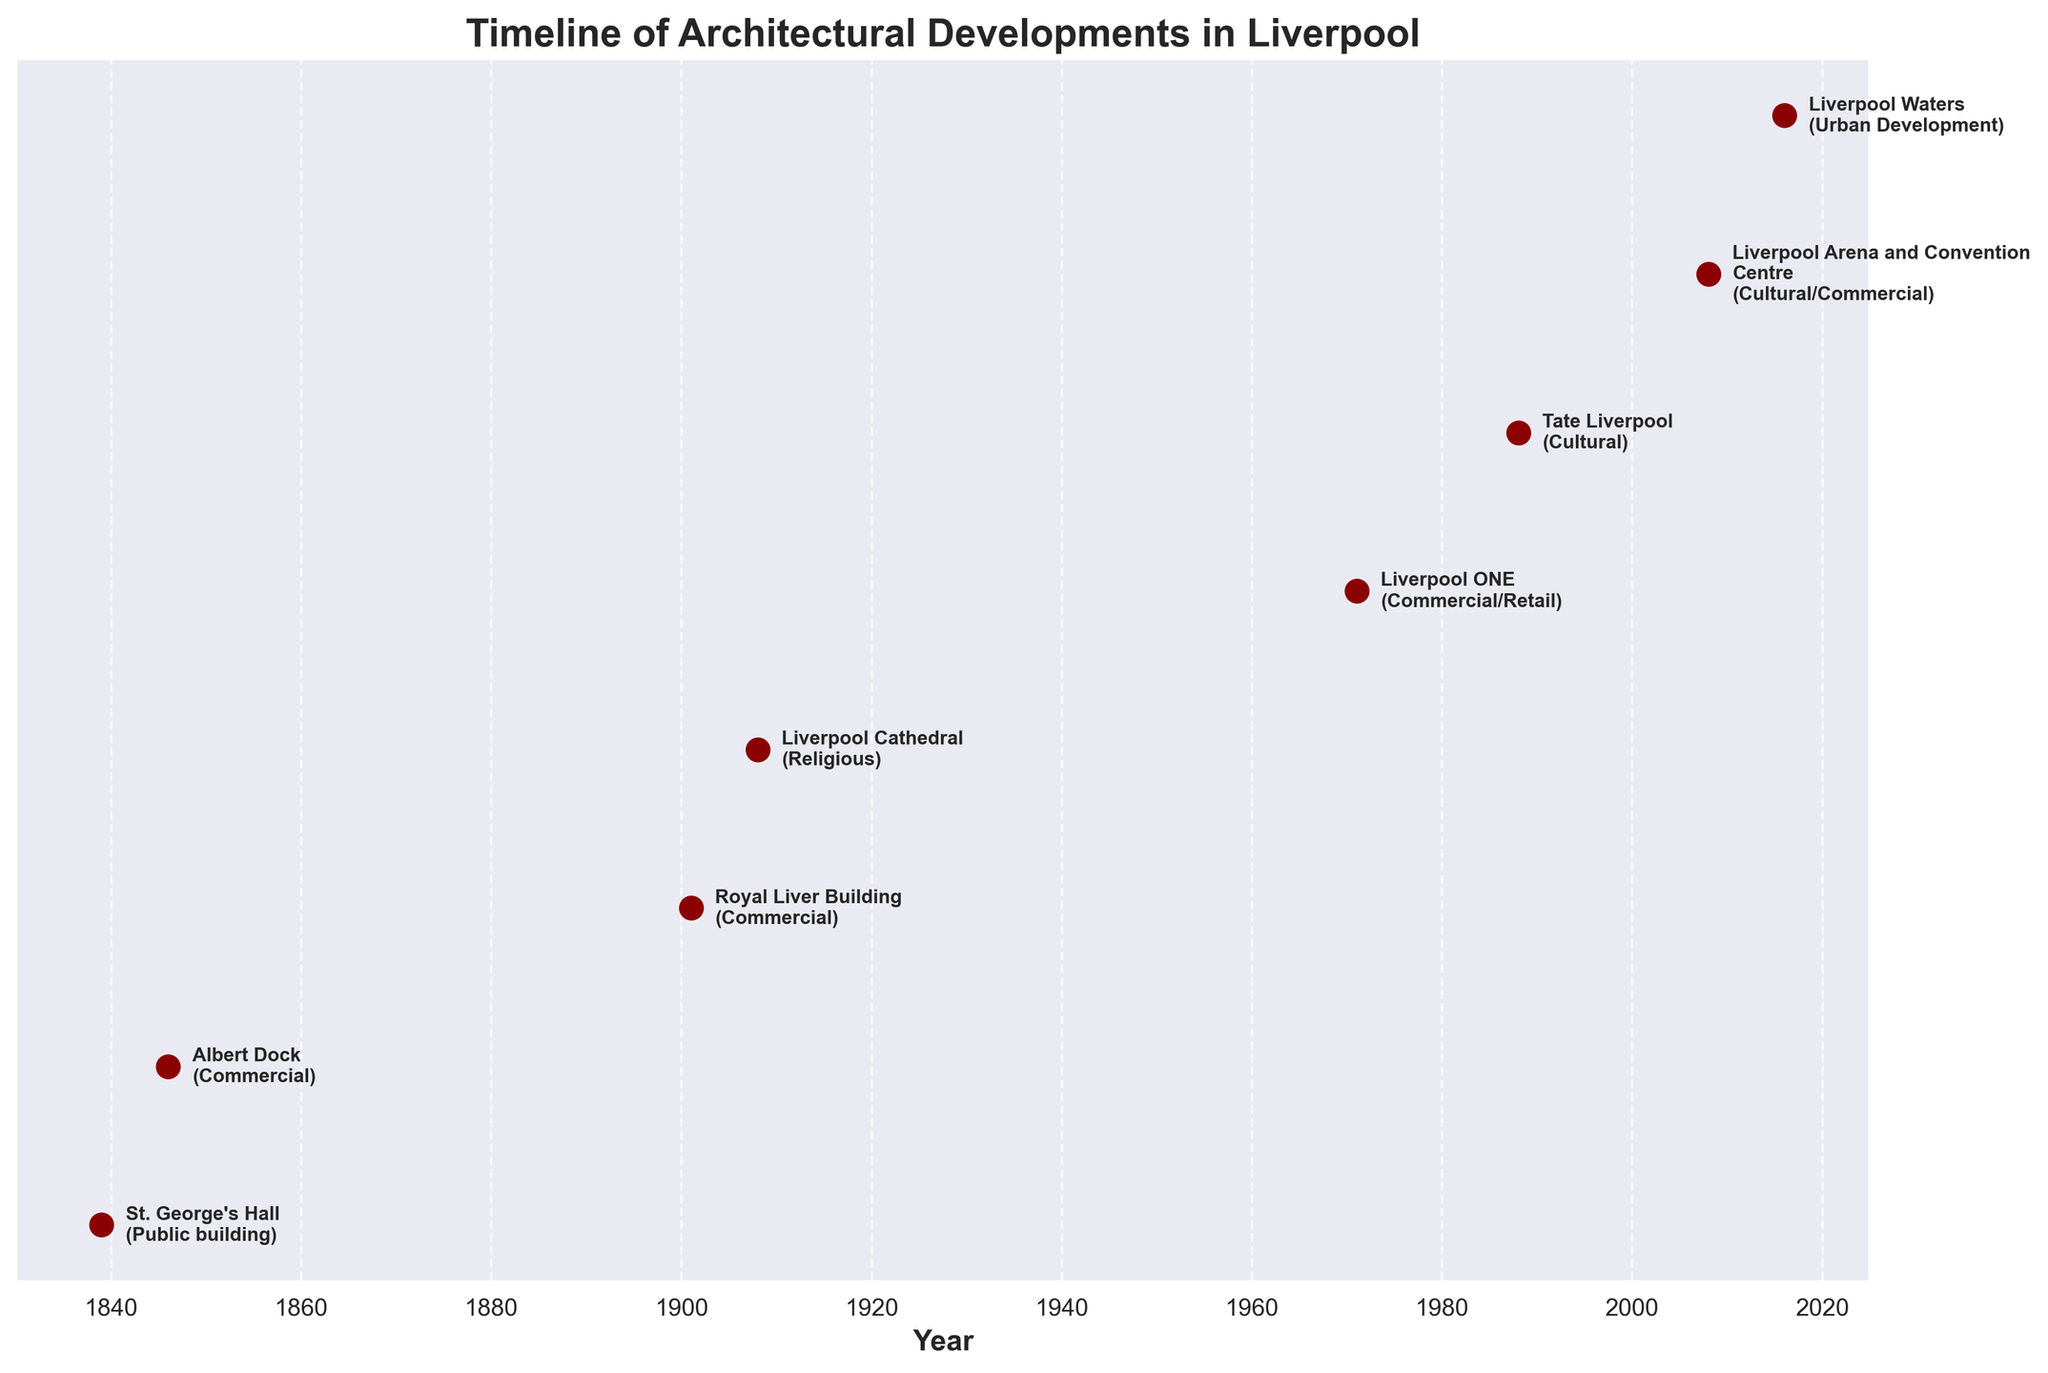what is the title of the chart? The title of the plot is displayed at the top of the figure and summarizes the main theme of the visualization.
Answer: Timeline of Architectural Developments in Liverpool How many projects are listed in the timeline? By counting the number of unique markers presented along the time axis, we can determine the total number of projects.
Answer: 8 Which project on the timeline was completed first? Look for the earliest date on the timeline and identify the corresponding project.
Answer: St. George's Hall What is the duration between the beginning of Liverpool Cathedral and the completion of Liverpool ONE? Identify the dates of these two projects (1908 for Liverpool Cathedral and 1971 for Liverpool ONE) and calculate the difference between these years.
Answer: 63 years Identify the projects that were completed during or after 2000. Look for the projects on the timeline whose dates are at or after the year 2000.
Answer: Liverpool Arena and Convention Centre (2008), Liverpool Waters (2016) Which type of project appears most frequently in the timeline? Count the occurrences of each project type (Public building, Commercial, Religious, Cultural, Urban Development) and identify the one with the highest count.
Answer: Commercial Estimate the average duration between consecutive project completions. Calculate the years between each consecutive pair of projects, sum these durations, and divide by the number of intervals (which is one less than the number of projects).
Answer: Approximately 25 years When was the Albert Dock completed relative to the Liverpool Cathedral construction's starting year? Compare the years for Albert Dock (1846) and Liverpool Cathedral (1908) to determine the time difference.
Answer: 62 years earlier Which project represents a major urban regeneration effort? Among the descriptions provided in the timeline, identify the one labeled as significant urban regeneration.
Answer: Liverpool Waters Identify and compare the time periods between the earliest and the most recent projects. What does this tell us about Liverpool's development? Find the years of the earliest (1839 for St. George's Hall) and most recent (2016 for Liverpool Waters) projects, and calculate the span. Analyze the timeline to understand the historical context.
Answer: Over 177 years, indicating continuous development 